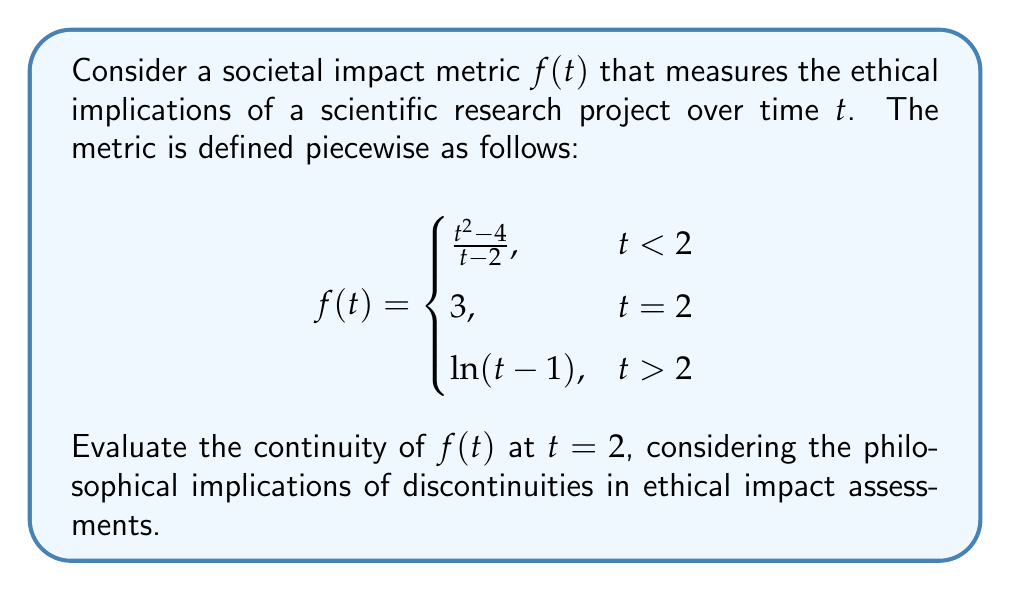Could you help me with this problem? To evaluate the continuity of $f(t)$ at $t = 2$, we need to check three conditions:

1. $f(2)$ is defined
2. $\lim_{t \to 2^-} f(t)$ exists
3. $\lim_{t \to 2^+} f(t)$ exists
4. $f(2) = \lim_{t \to 2^-} f(t) = \lim_{t \to 2^+} f(t)$

Step 1: $f(2)$ is defined and equals 3.

Step 2: Evaluate $\lim_{t \to 2^-} f(t)$
$$\lim_{t \to 2^-} f(t) = \lim_{t \to 2^-} \frac{t^2 - 4}{t - 2}$$
This is an indeterminate form (0/0). Apply L'Hôpital's rule:
$$\lim_{t \to 2^-} \frac{t^2 - 4}{t - 2} = \lim_{t \to 2^-} \frac{2t}{1} = 4$$

Step 3: Evaluate $\lim_{t \to 2^+} f(t)$
$$\lim_{t \to 2^+} f(t) = \lim_{t \to 2^+} \ln(t - 1) = \ln(1) = 0$$

Step 4: Compare the values
$f(2) = 3$
$\lim_{t \to 2^-} f(t) = 4$
$\lim_{t \to 2^+} f(t) = 0$

Since these three values are not equal, $f(t)$ is not continuous at $t = 2$.

Philosophical implication: The discontinuity at $t = 2$ suggests a sudden shift in the ethical impact assessment of the research project. This abrupt change may indicate a critical point in the study where the ethical implications fundamentally change, requiring careful consideration and potentially new ethical frameworks for evaluation.
Answer: $f(t)$ is discontinuous at $t = 2$ 